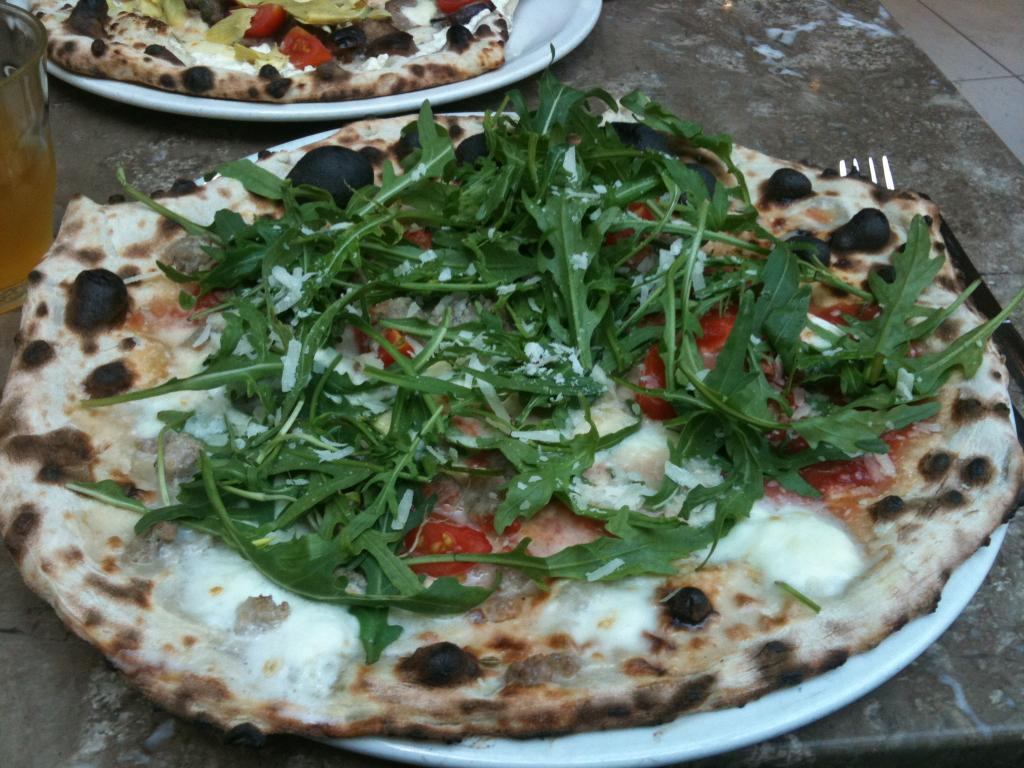What type of food is on the plate in the image? There is a pizza on a plate in the image. What else can be seen on the table in the image? There is a glass and another plate in the image. Where is the other plate located in relation to the pizza? The other plate is located at the top side of the image. What utensil is visible in the image? There is a fork on the right side of the image. Can you tell me how many baseballs are on the table in the image? There are no baseballs present in the image. Is there anyone driving a car in the image? There is no car or driving activity depicted in the image. 